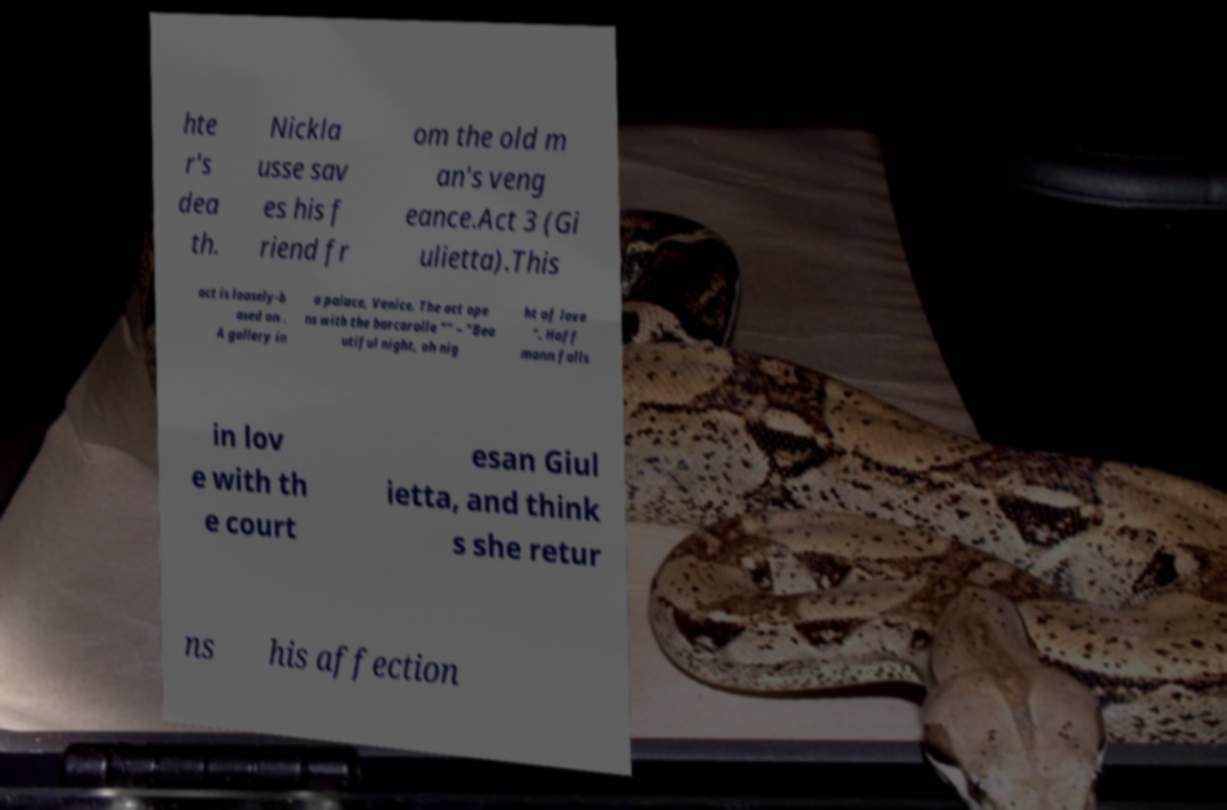Could you assist in decoding the text presented in this image and type it out clearly? hte r's dea th. Nickla usse sav es his f riend fr om the old m an's veng eance.Act 3 (Gi ulietta).This act is loosely-b ased on . A gallery in a palace, Venice. The act ope ns with the barcarolle "" – "Bea utiful night, oh nig ht of love ". Hoff mann falls in lov e with th e court esan Giul ietta, and think s she retur ns his affection 